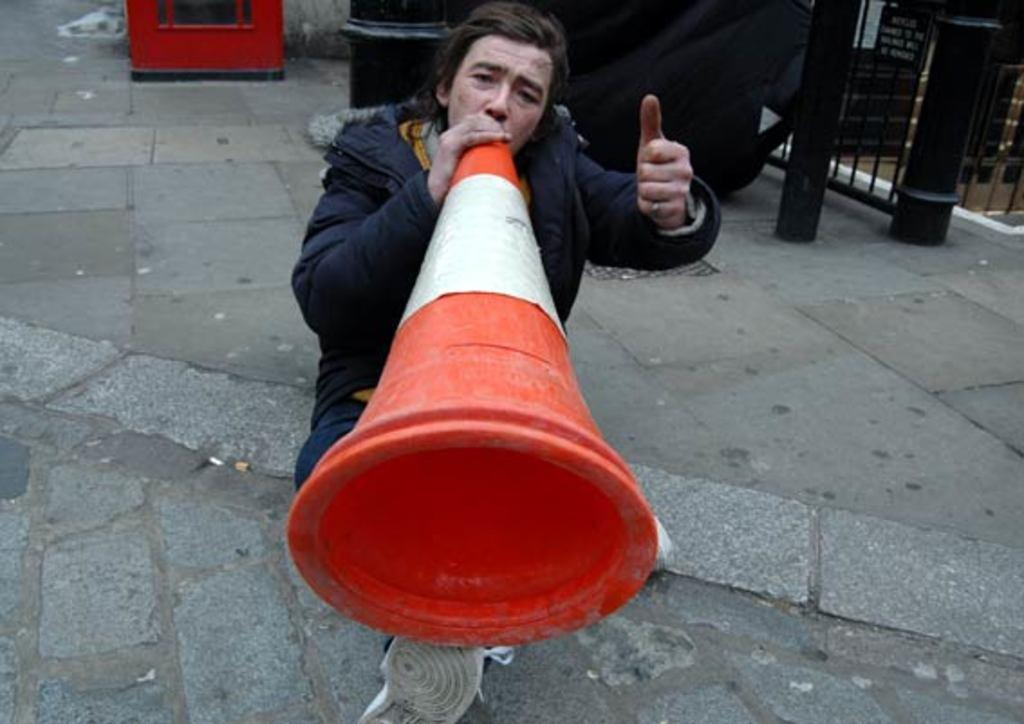What can be seen in the image? There is a person in the image. Can you describe the person's attire? The person is wearing clothes. What is the person holding in the image? The person is holding a divider cone. What else is visible in the image? There are poles in the top right of the image. Are there any farm animals visible in the image? No, there are no farm animals present in the image. Can you see any cobwebs in the image? No, there are no cobwebs visible in the image. 